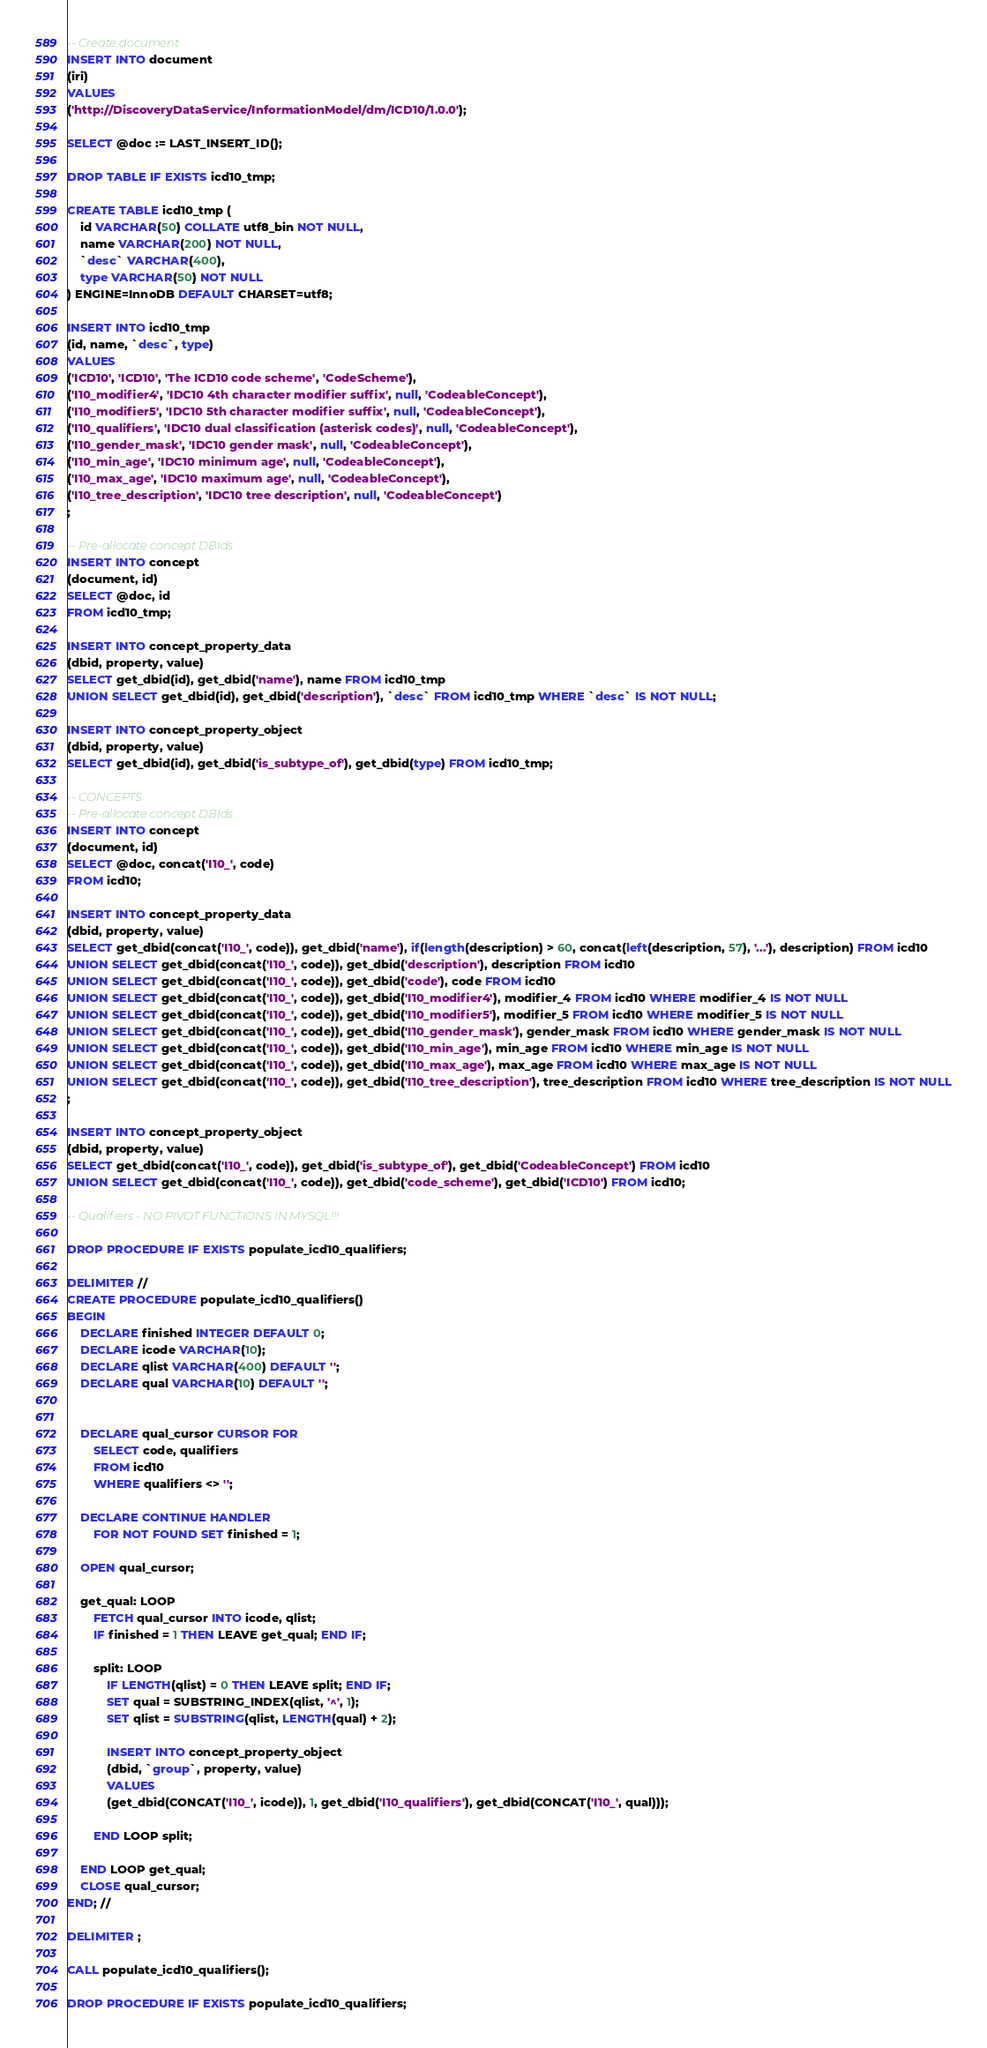Convert code to text. <code><loc_0><loc_0><loc_500><loc_500><_SQL_>-- Create document
INSERT INTO document
(iri)
VALUES
('http://DiscoveryDataService/InformationModel/dm/ICD10/1.0.0');

SELECT @doc := LAST_INSERT_ID();

DROP TABLE IF EXISTS icd10_tmp;

CREATE TABLE icd10_tmp (
    id VARCHAR(50) COLLATE utf8_bin NOT NULL,
    name VARCHAR(200) NOT NULL,
    `desc` VARCHAR(400),
    type VARCHAR(50) NOT NULL
) ENGINE=InnoDB DEFAULT CHARSET=utf8;

INSERT INTO icd10_tmp
(id, name, `desc`, type)
VALUES
('ICD10', 'ICD10', 'The ICD10 code scheme', 'CodeScheme'),
('I10_modifier4', 'IDC10 4th character modifier suffix', null, 'CodeableConcept'),
('I10_modifier5', 'IDC10 5th character modifier suffix', null, 'CodeableConcept'),
('I10_qualifiers', 'IDC10 dual classification (asterisk codes)', null, 'CodeableConcept'),
('I10_gender_mask', 'IDC10 gender mask', null, 'CodeableConcept'),
('I10_min_age', 'IDC10 minimum age', null, 'CodeableConcept'),
('I10_max_age', 'IDC10 maximum age', null, 'CodeableConcept'),
('I10_tree_description', 'IDC10 tree description', null, 'CodeableConcept')
;

-- Pre-allocate concept DBIds
INSERT INTO concept
(document, id)
SELECT @doc, id
FROM icd10_tmp;

INSERT INTO concept_property_data
(dbid, property, value)
SELECT get_dbid(id), get_dbid('name'), name FROM icd10_tmp
UNION SELECT get_dbid(id), get_dbid('description'), `desc` FROM icd10_tmp WHERE `desc` IS NOT NULL;

INSERT INTO concept_property_object
(dbid, property, value)
SELECT get_dbid(id), get_dbid('is_subtype_of'), get_dbid(type) FROM icd10_tmp;

-- CONCEPTS
-- Pre-allocate concept DBIds
INSERT INTO concept
(document, id)
SELECT @doc, concat('I10_', code)
FROM icd10;

INSERT INTO concept_property_data
(dbid, property, value)
SELECT get_dbid(concat('I10_', code)), get_dbid('name'), if(length(description) > 60, concat(left(description, 57), '...'), description) FROM icd10
UNION SELECT get_dbid(concat('I10_', code)), get_dbid('description'), description FROM icd10
UNION SELECT get_dbid(concat('I10_', code)), get_dbid('code'), code FROM icd10
UNION SELECT get_dbid(concat('I10_', code)), get_dbid('I10_modifier4'), modifier_4 FROM icd10 WHERE modifier_4 IS NOT NULL
UNION SELECT get_dbid(concat('I10_', code)), get_dbid('I10_modifier5'), modifier_5 FROM icd10 WHERE modifier_5 IS NOT NULL
UNION SELECT get_dbid(concat('I10_', code)), get_dbid('I10_gender_mask'), gender_mask FROM icd10 WHERE gender_mask IS NOT NULL
UNION SELECT get_dbid(concat('I10_', code)), get_dbid('I10_min_age'), min_age FROM icd10 WHERE min_age IS NOT NULL
UNION SELECT get_dbid(concat('I10_', code)), get_dbid('I10_max_age'), max_age FROM icd10 WHERE max_age IS NOT NULL
UNION SELECT get_dbid(concat('I10_', code)), get_dbid('I10_tree_description'), tree_description FROM icd10 WHERE tree_description IS NOT NULL
;

INSERT INTO concept_property_object
(dbid, property, value)
SELECT get_dbid(concat('I10_', code)), get_dbid('is_subtype_of'), get_dbid('CodeableConcept') FROM icd10
UNION SELECT get_dbid(concat('I10_', code)), get_dbid('code_scheme'), get_dbid('ICD10') FROM icd10;

-- Qualifiers - NO PIVOT FUNCTIONS IN MYSQL!!!

DROP PROCEDURE IF EXISTS populate_icd10_qualifiers;

DELIMITER //
CREATE PROCEDURE populate_icd10_qualifiers()
BEGIN
    DECLARE finished INTEGER DEFAULT 0;
    DECLARE icode VARCHAR(10);
    DECLARE qlist VARCHAR(400) DEFAULT '';
    DECLARE qual VARCHAR(10) DEFAULT '';


    DECLARE qual_cursor CURSOR FOR
        SELECT code, qualifiers
        FROM icd10
        WHERE qualifiers <> '';

    DECLARE CONTINUE HANDLER
        FOR NOT FOUND SET finished = 1;

    OPEN qual_cursor;

    get_qual: LOOP
        FETCH qual_cursor INTO icode, qlist;
        IF finished = 1 THEN LEAVE get_qual; END IF;

        split: LOOP
            IF LENGTH(qlist) = 0 THEN LEAVE split; END IF;
            SET qual = SUBSTRING_INDEX(qlist, '^', 1);
            SET qlist = SUBSTRING(qlist, LENGTH(qual) + 2);

            INSERT INTO concept_property_object
            (dbid, `group`, property, value)
            VALUES
            (get_dbid(CONCAT('I10_', icode)), 1, get_dbid('I10_qualifiers'), get_dbid(CONCAT('I10_', qual)));

        END LOOP split;

    END LOOP get_qual;
    CLOSE qual_cursor;
END; //

DELIMITER ;

CALL populate_icd10_qualifiers();

DROP PROCEDURE IF EXISTS populate_icd10_qualifiers;
</code> 